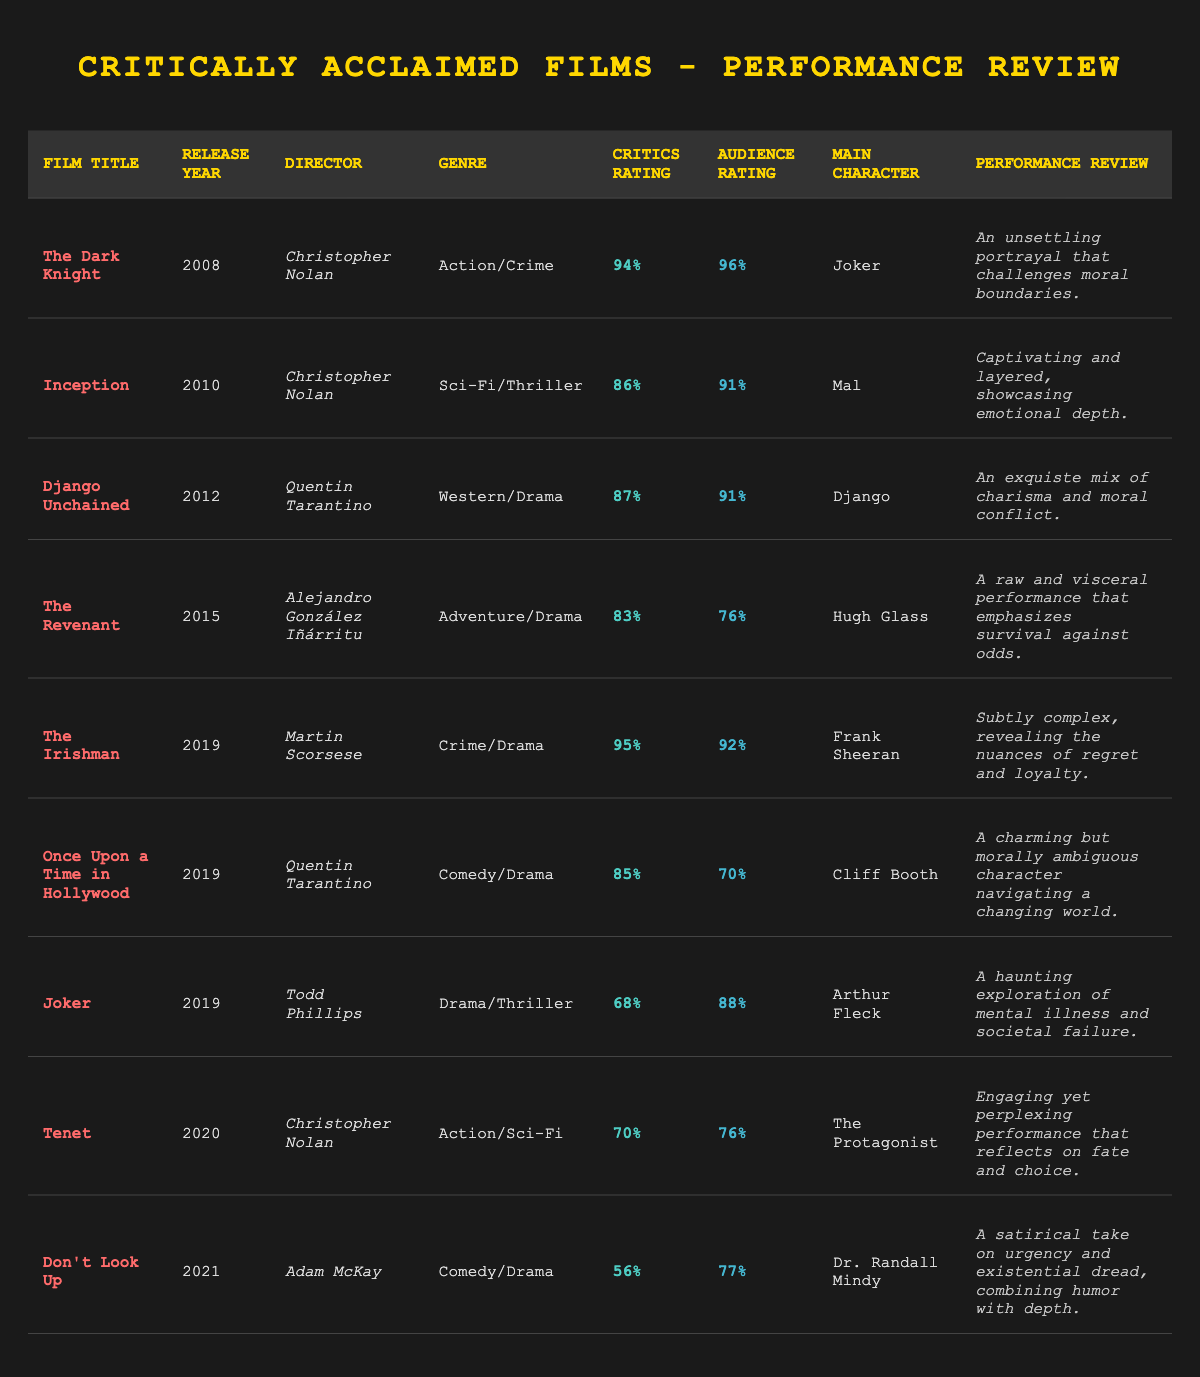What is the highest critics rating among the films? The critics rating for each film needs to be compared. "The Irishman" has the highest critics rating of 95%.
Answer: 95% Which film received the lowest audience rating? The audience ratings are checked, with "Once Upon a Time in Hollywood" having the lowest at 70%.
Answer: 70% How many films did the actor star in that were directed by Quentin Tarantino? There are two films directed by Tarantino in the table: "Django Unchained" and "Once Upon a Time in Hollywood."
Answer: 2 What percentage difference is there between the critics and audience ratings for "The Revenant"? The critics rating for "The Revenant" is 83% and the audience rating is 76%. The difference is 83 - 76 = 7%.
Answer: 7% Did any film have a critics rating of less than 70%? Checking all critics ratings, "Joker" has a critics rating of 68%, which is less than 70%.
Answer: Yes What was the most recent film listed? The most recent release year in the table is 2021 with "Don't Look Up."
Answer: Don't Look Up Which film has a performance review mentioning "moral conflict"? "Django Unchained" has "An exquisite mix of charisma and moral conflict" in its performance review.
Answer: Django Unchained What are the average critics ratings for films released after 2015? Calculating the critics ratings for 2019 and 2021 films: "The Irishman" (95), "Once Upon a Time in Hollywood" (85), "Joker" (68), "Tenet" (70), "Don't Look Up" (56). The average is (95 + 85 + 68 + 70 + 56) / 5 = 74.
Answer: 74 What genre does "Inception" belong to? Referring to the table, "Inception" is categorized as Sci-Fi/Thriller.
Answer: Sci-Fi/Thriller Which film had the main character named "Arthur Fleck"? The table indicates that "Joker" features Arthur Fleck as the main character.
Answer: Joker What is the relationship between critics ratings and audience ratings for "Tenet"? "Tenet" has a critics rating of 70% and an audience rating of 76%, showing that audience ratings are higher by 6%.
Answer: Audience ratings are higher by 6% 